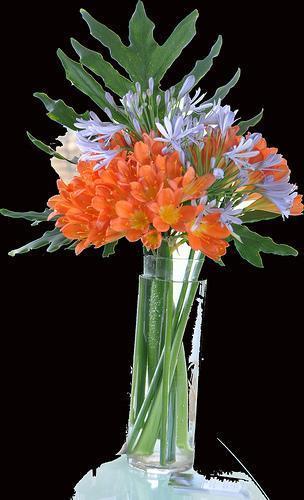How many different colors of flowers are there?
Give a very brief answer. 2. 